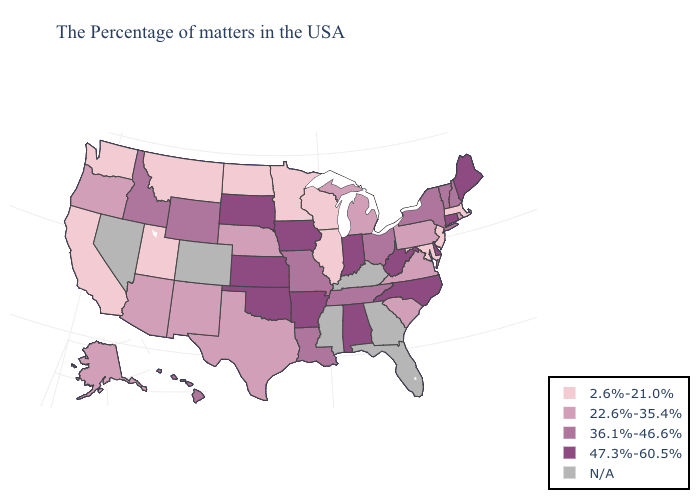What is the lowest value in states that border Texas?
Be succinct. 22.6%-35.4%. Among the states that border Maine , which have the highest value?
Answer briefly. New Hampshire. Name the states that have a value in the range N/A?
Answer briefly. Florida, Georgia, Kentucky, Mississippi, Colorado, Nevada. Name the states that have a value in the range 36.1%-46.6%?
Answer briefly. New Hampshire, Vermont, New York, Ohio, Tennessee, Louisiana, Missouri, Wyoming, Idaho, Hawaii. Does Virginia have the lowest value in the USA?
Be succinct. No. What is the value of Massachusetts?
Quick response, please. 2.6%-21.0%. What is the highest value in the South ?
Give a very brief answer. 47.3%-60.5%. What is the highest value in states that border Georgia?
Be succinct. 47.3%-60.5%. Does the map have missing data?
Answer briefly. Yes. What is the lowest value in states that border Virginia?
Give a very brief answer. 2.6%-21.0%. What is the highest value in the USA?
Quick response, please. 47.3%-60.5%. What is the value of Nevada?
Quick response, please. N/A. Does the map have missing data?
Write a very short answer. Yes. What is the lowest value in the West?
Quick response, please. 2.6%-21.0%. Which states have the lowest value in the USA?
Short answer required. Massachusetts, New Jersey, Maryland, Wisconsin, Illinois, Minnesota, North Dakota, Utah, Montana, California, Washington. 